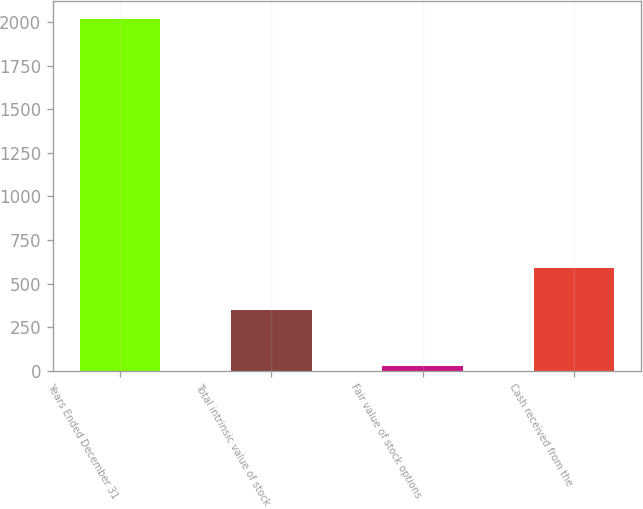<chart> <loc_0><loc_0><loc_500><loc_500><bar_chart><fcel>Years Ended December 31<fcel>Total intrinsic value of stock<fcel>Fair value of stock options<fcel>Cash received from the<nl><fcel>2018<fcel>348<fcel>29<fcel>591<nl></chart> 